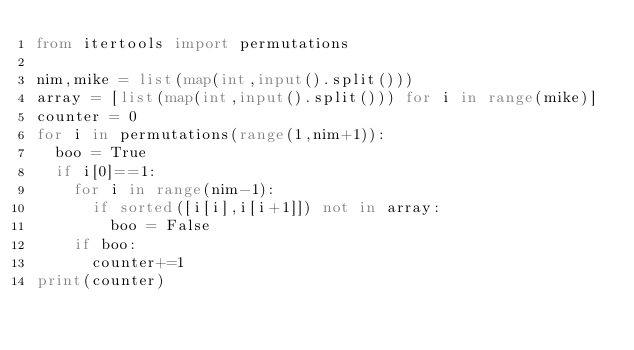Convert code to text. <code><loc_0><loc_0><loc_500><loc_500><_Python_>from itertools import permutations

nim,mike = list(map(int,input().split()))
array = [list(map(int,input().split())) for i in range(mike)]
counter = 0
for i in permutations(range(1,nim+1)):
  boo = True
  if i[0]==1:
    for i in range(nim-1):
      if sorted([i[i],i[i+1]]) not in array:
        boo = False
    if boo:
      counter+=1
print(counter)</code> 